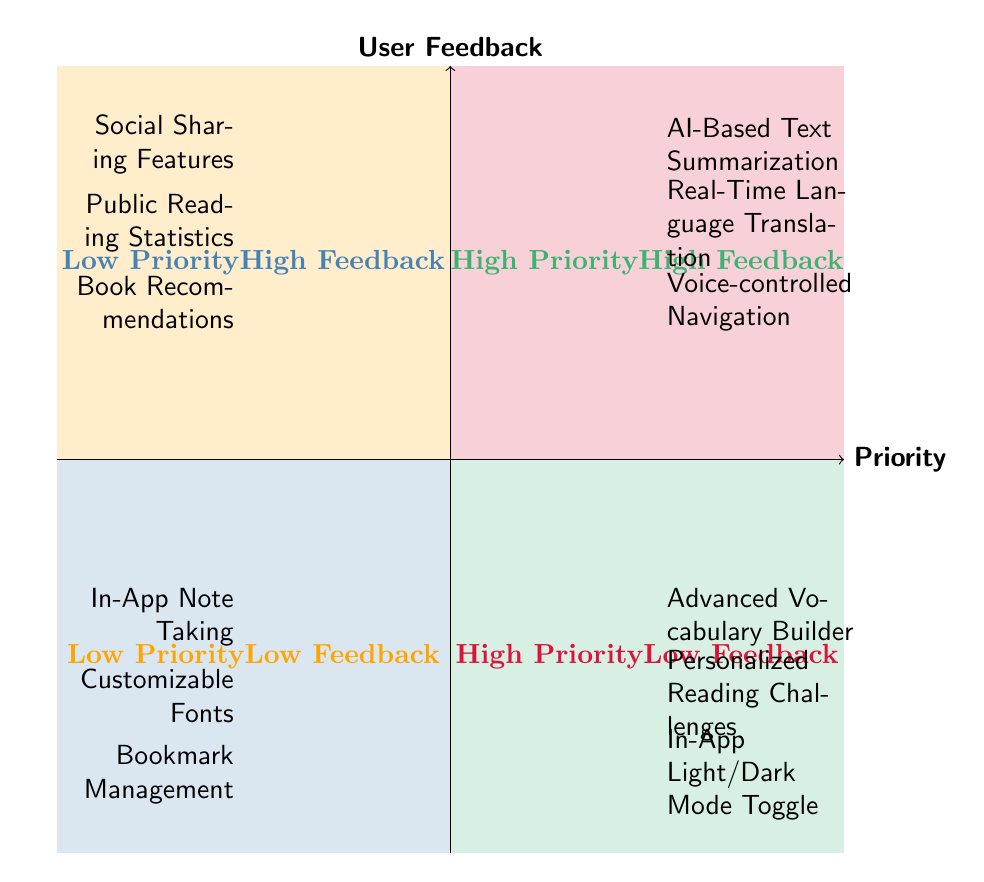What features are found in the high priority, high feedback quadrant? The high priority, high feedback quadrant includes features that have both high priority and high user feedback. By looking at the upper right section of the diagram, we identify three listed features: AI-Based Text Summarization, Real-Time Language Translation, and Voice-controlled Navigation.
Answer: AI-Based Text Summarization, Real-Time Language Translation, Voice-controlled Navigation How many features are in the low priority, high feedback quadrant? In the low priority, high feedback quadrant, we can count the number of features listed. There are three features: Social Sharing Features, Public Reading Statistics, and Book Recommendations. Thus, the total is three.
Answer: 3 What is the unique feature in the low priority, low feedback quadrant? The low priority, low feedback quadrant features three listed elements. They are In-App Note Taking, Customizable Fonts, and Bookmark Management. Thus, there is no unique feature; all three are equally important but not prioritized or receiving user feedback.
Answer: None Which quadrant has the highest number of features? Comparing quadrants, the high priority, high feedback, and low priority, low feedback quadrants each have three features, while the high priority, low feedback quadrant has three features, and the low priority, high feedback quadrant also has three. Hence, all quadrants have equal numbers of features. There is no defined “highest” here.
Answer: All quadrants have equal features What characteristics define features in the high priority, low feedback quadrant? The high priority, low feedback quadrant indicates that the listed features prioritize importance but have received low levels of user feedback. The three features here are Advanced Vocabulary Builder, Personalized Reading Challenges, and In-App Light/Dark Mode Toggle. These features may have been deemed essential by the developers but are not popular with users.
Answer: Prioritized but low user feedback Which features are most likely to improve user engagement? To determine which features may enhance user engagement, we look at the high priority, high feedback quadrant where features like AI-Based Text Summarization and Real-Time Language Translation may be pivotal. According to user trends, engagement typically improves when users can better navigate, understand, and utilize content.
Answer: AI-Based Text Summarization, Real-Time Language Translation How do features in the low priority, high feedback quadrant differ from those in the high priority, low feedback quadrant? The low priority, high feedback quadrant includes features that are well-received by users but are not essential, like Social Sharing Features, whereas the high priority, low feedback quadrant contains features prioritized for importance but lacks user approval, such as Advanced Vocabulary Builder. This indicates a gap between developer priority and user evaluation.
Answer: High user appreciation vs. high developer priority Which two features could be candidates for further development based on feedback? By assessing both feedback and priority, we consider features in the high priority, low feedback quadrant for potential development. Specifically, two features, Advanced Vocabulary Builder and Personalized Reading Challenges, should be further developed since they hold high priority but failed to attract user feedback.
Answer: Advanced Vocabulary Builder, Personalized Reading Challenges 